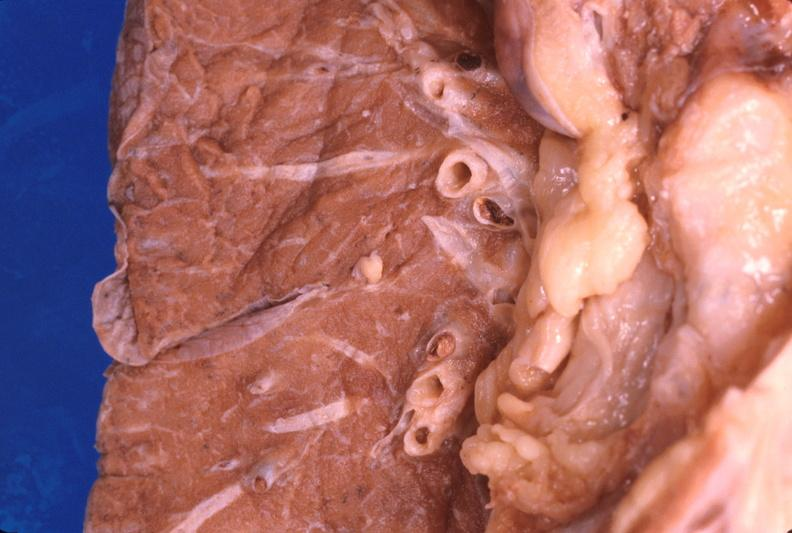where is this?
Answer the question using a single word or phrase. Lung 